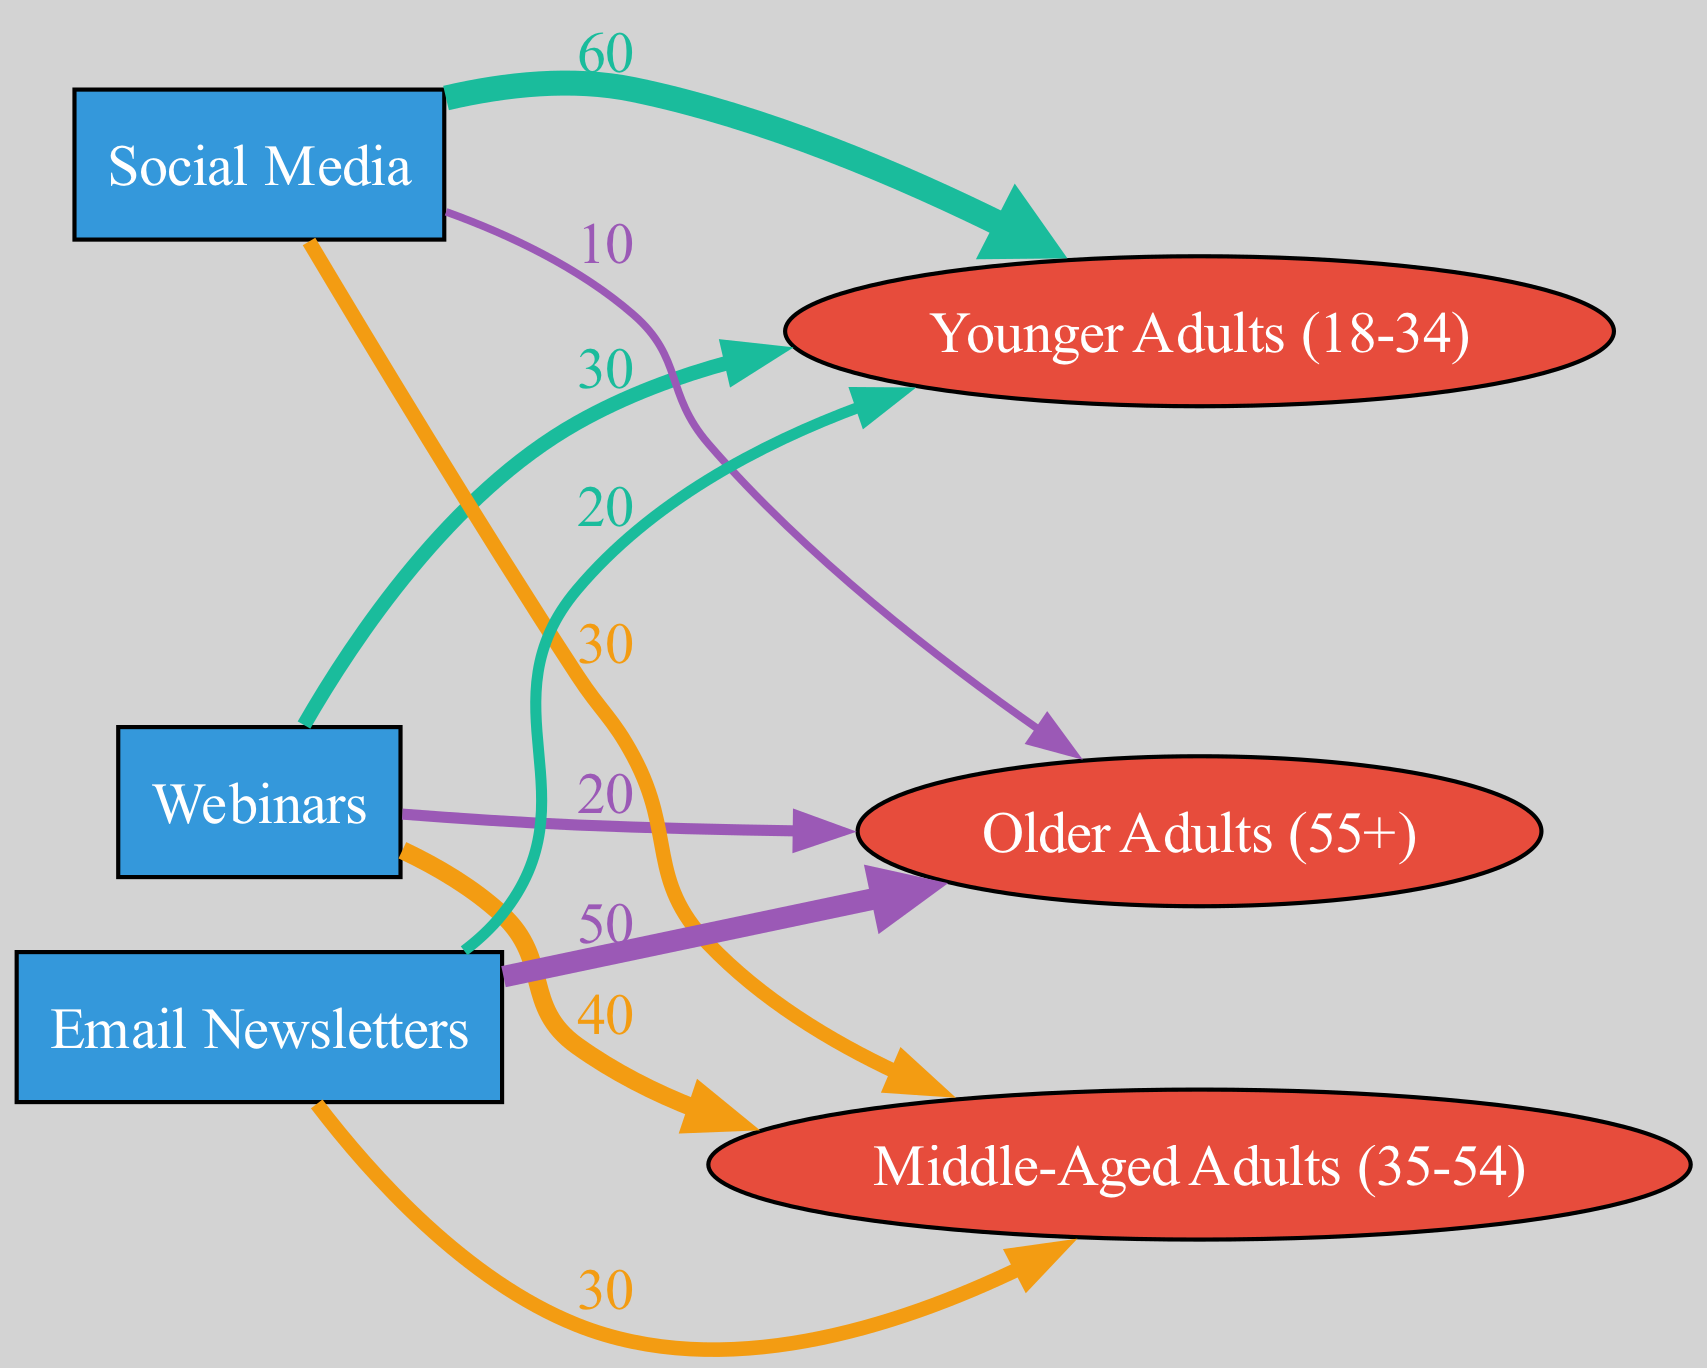What age group shows the highest preference for Social Media? By examining the links connected to Social Media, we find the values for the three age groups. Younger Adults (18-34) have a value of 60, Middle-Aged Adults (35-54) have 30, and Older Adults (55+) have 10. Therefore, Younger Adults (18-34) show the highest preference for Social Media.
Answer: Younger Adults (18-34) How many total age groups are represented in the diagram? Looking at the node section, there are three distinct age groups listed: Younger Adults (18-34), Middle-Aged Adults (35-54), and Older Adults (55+). This gives us a total count of three age groups.
Answer: 3 What is the value link for Older Adults using Email Newsletters? In the links, we find that Email Newsletters link to Older Adults (55+) with a value of 50. This indicates the preference for Email Newsletters among this age group.
Answer: 50 Which communication tool has the highest overall preference among Younger Adults? For Younger Adults (18-34), the values for the tools are: Webinars (30), Social Media (60), and Email Newsletters (20). Social Media has the highest value at 60, indicating it is the most preferred tool by this age group.
Answer: Social Media What is the combined value of Webinars among all age groups? By adding the individual values of Webinars linked to each age group, we have: 30 (Younger Adults) + 40 (Middle-Aged Adults) + 20 (Older Adults) = 90. Thus, the combined value for Webinars is 90.
Answer: 90 How does the preference for Email Newsletters compare between Younger and Older Adults? The value for Younger Adults with Email Newsletters is 20, while for Older Adults it is 50. Comparing these values shows that Older Adults have a significantly higher preference for Email Newsletters than Younger Adults.
Answer: Older Adults have a higher preference What percentage of Older Adults prefer Webinars compared to all the tools? The total values for Older Adults are: Webinars (20), Social Media (10), and Email Newsletters (50). The total is 20 + 10 + 50 = 80. The percentage for Webinars is (20/80)*100 = 25%.
Answer: 25% Which communication tool has the widest distribution preference among the age groups? By examining the links, we can see that Social Media links to all three age groups with varying values (60, 30, and 10), while others link with lower collective reach. Thus, Social Media covers all age groups widely with higher values overall.
Answer: Social Media 